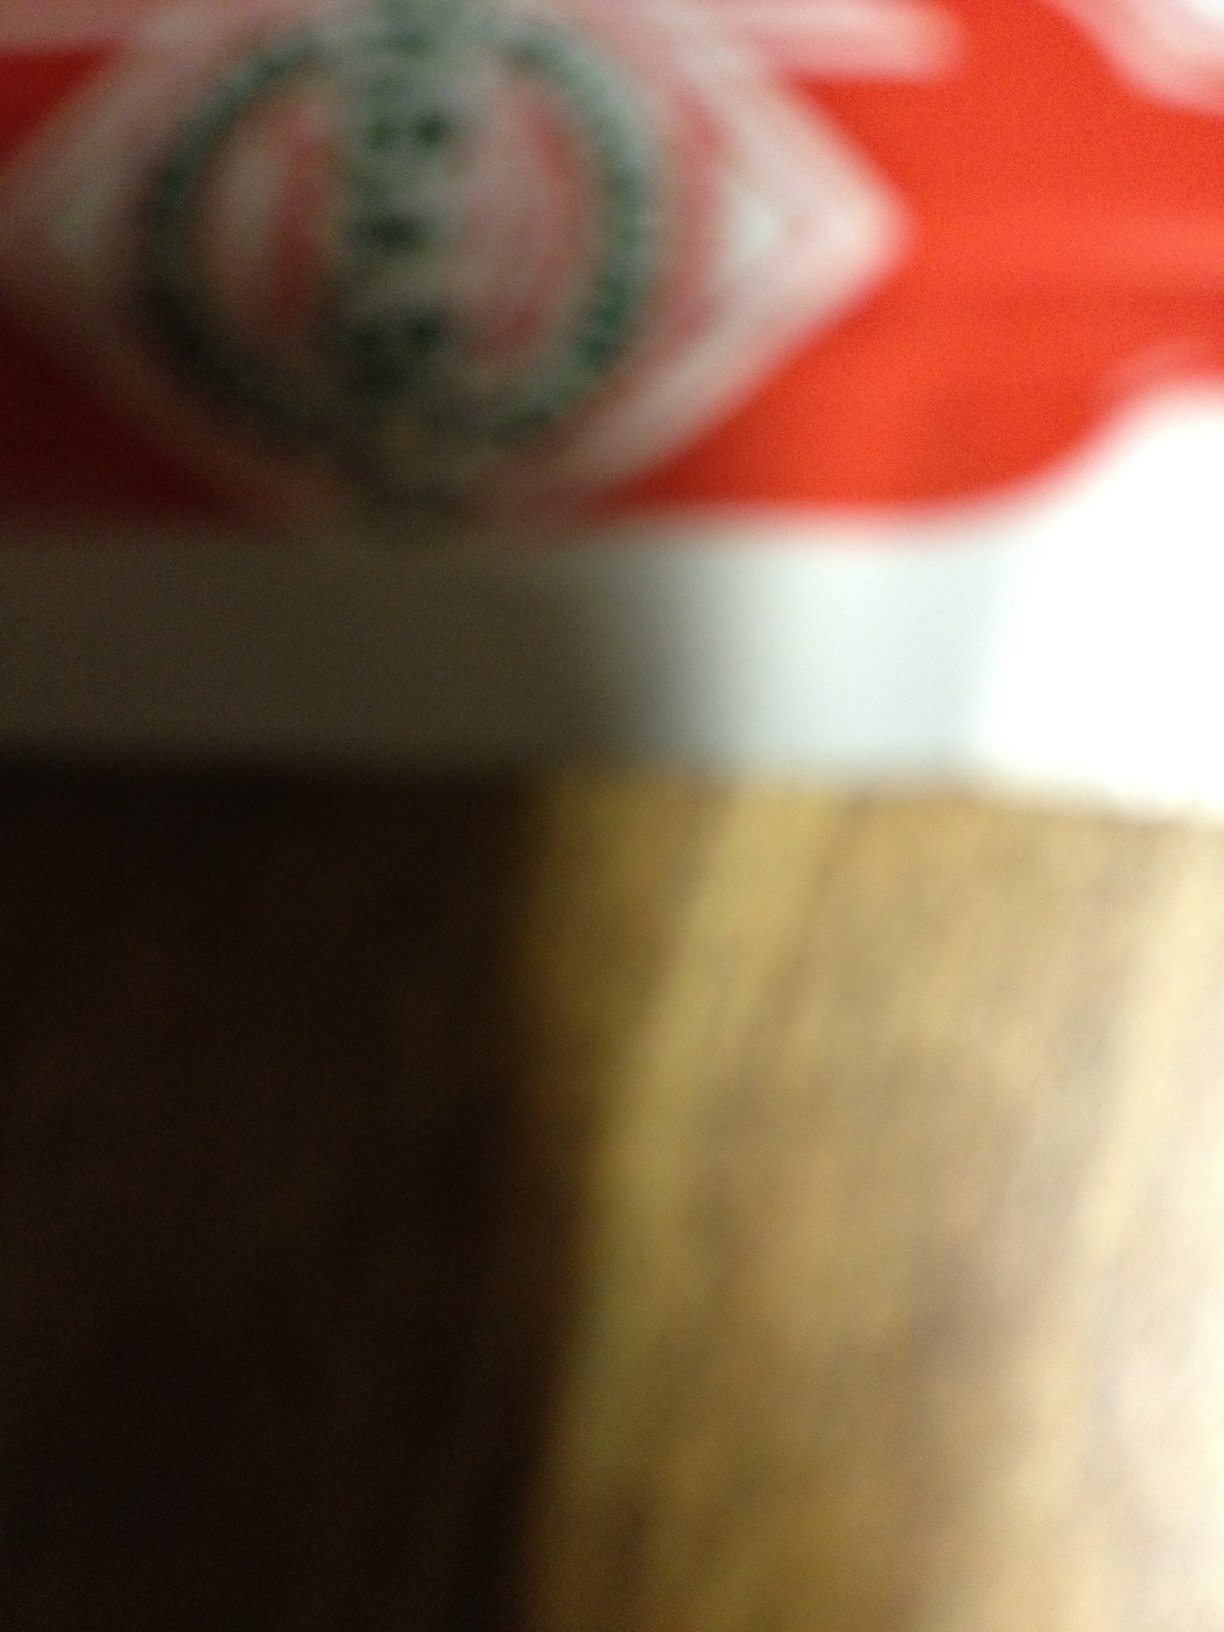What type of material does the packaging seem to be made from? The blurry image shows a glossy surface, suggesting that the packaging could be plastic or coated paper typically used in consumer goods packaging. 